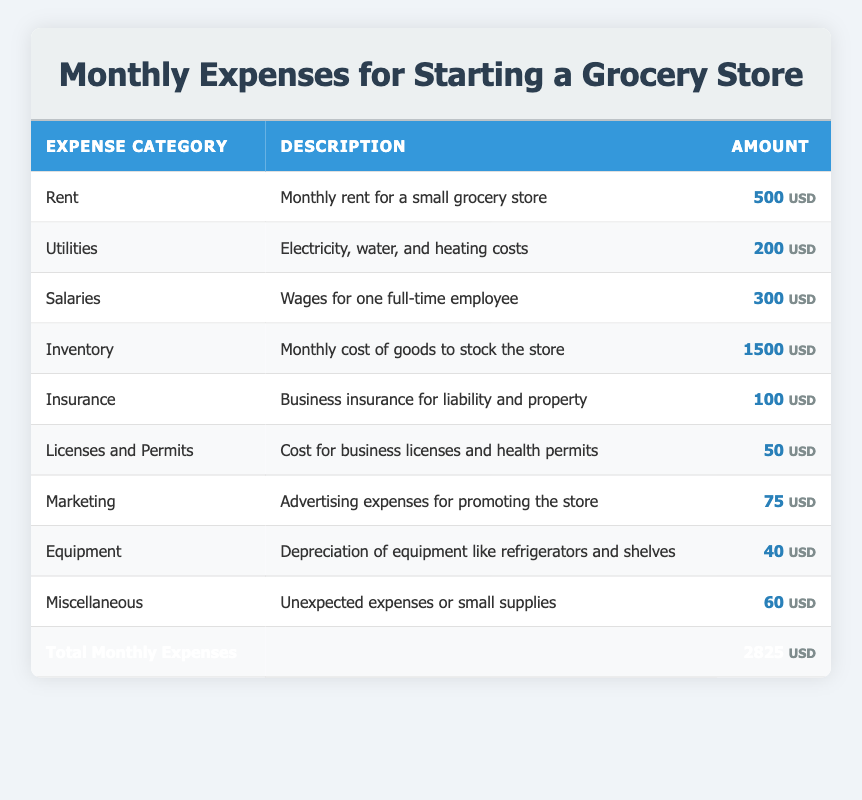What is the total monthly expense for starting a grocery store? The total monthly expense is listed in the last row of the table. It shows the sum of all expenses, which is 2825 USD.
Answer: 2825 USD How much is allocated to inventory each month? The 'Inventory' row specifies the monthly cost allocated for inventory, which is 1500 USD.
Answer: 1500 USD Is the monthly cost for insurance more than the cost for marketing? The insurance cost is 100 USD, and the marketing cost is 75 USD. Since 100 is greater than 75, the statement is true.
Answer: Yes What are the total fixed costs (Rent, Utilities, Salaries, Insurance, and Licenses and Permits)? To find the total fixed costs, add the amounts from the relevant categories: Rent (500) + Utilities (200) + Salaries (300) + Insurance (100) + Licenses and Permits (50) = 1150 USD.
Answer: 1150 USD Which expense category has the highest monthly cost? By comparing the amounts in each row, the 'Inventory' category has the highest cost, which is 1500 USD.
Answer: Inventory How much more does the grocery store spend on inventory compared to salaries? The inventory cost is 1500 USD, while the salaries cost is 300 USD. The difference is 1500 - 300 = 1200 USD.
Answer: 1200 USD Is marketing expense the lowest among all categories? The marketing cost is 75 USD, and the lowest cost is for 'Equipment' at 40 USD. Since 75 is greater than 40, the statement is false.
Answer: No What is the total cost for utilities and equipment combined? To find the total for utilities and equipment, add the amounts: Utilities (200) + Equipment (40) = 240 USD.
Answer: 240 USD If you exclude the inventory expense, what are the remaining total monthly expenses? To find this total, sum all the expenses except 'Inventory': 500 (Rent) + 200 (Utilities) + 300 (Salaries) + 100 (Insurance) + 50 (Licenses and Permits) + 75 (Marketing) + 40 (Equipment) + 60 (Miscellaneous) = 1325 USD.
Answer: 1325 USD 